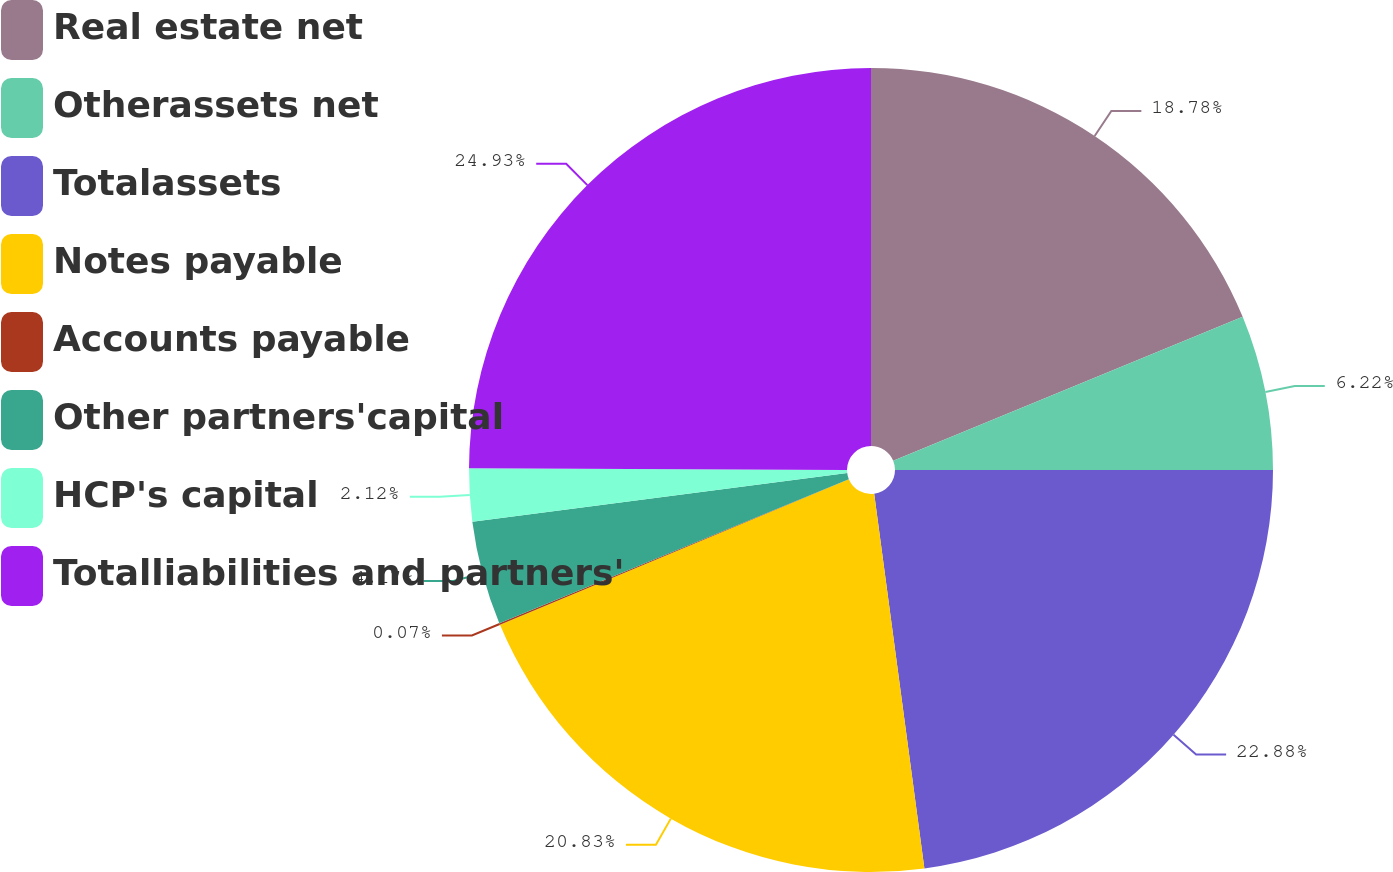<chart> <loc_0><loc_0><loc_500><loc_500><pie_chart><fcel>Real estate net<fcel>Otherassets net<fcel>Totalassets<fcel>Notes payable<fcel>Accounts payable<fcel>Other partners'capital<fcel>HCP's capital<fcel>Totalliabilities and partners'<nl><fcel>18.78%<fcel>6.22%<fcel>22.88%<fcel>20.83%<fcel>0.07%<fcel>4.17%<fcel>2.12%<fcel>24.93%<nl></chart> 